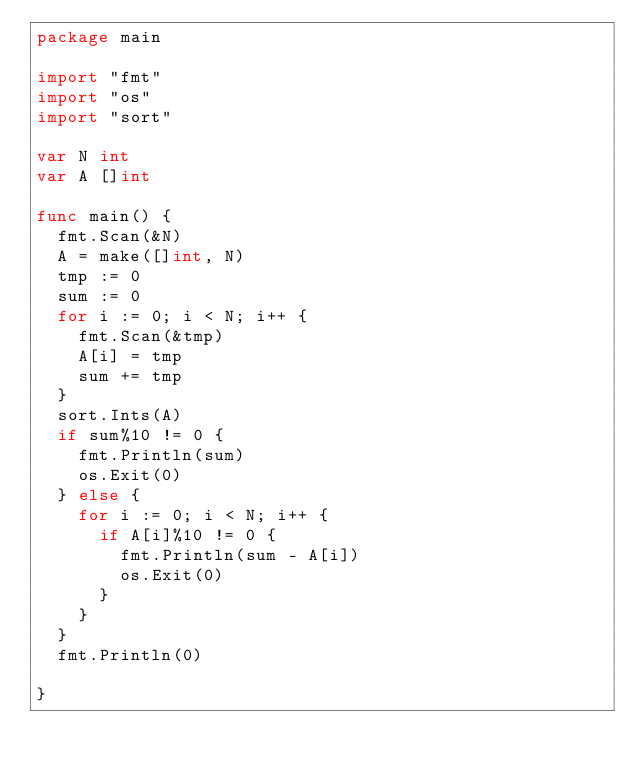Convert code to text. <code><loc_0><loc_0><loc_500><loc_500><_Go_>package main

import "fmt"
import "os"
import "sort"

var N int
var A []int

func main() {
	fmt.Scan(&N)
	A = make([]int, N)
	tmp := 0
	sum := 0
	for i := 0; i < N; i++ {
		fmt.Scan(&tmp)
		A[i] = tmp
		sum += tmp
	}
	sort.Ints(A)
	if sum%10 != 0 {
		fmt.Println(sum)
		os.Exit(0)
	} else {
		for i := 0; i < N; i++ {
			if A[i]%10 != 0 {
				fmt.Println(sum - A[i])
				os.Exit(0)
			}
		}
	}
	fmt.Println(0)

}
</code> 